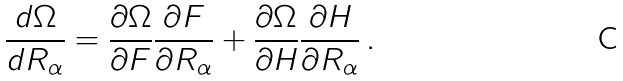Convert formula to latex. <formula><loc_0><loc_0><loc_500><loc_500>\frac { d \Omega } { d R _ { \alpha } } = \frac { \partial \Omega } { \partial F } \frac { \partial F } { \partial R _ { \alpha } } + \frac { \partial \Omega } { \partial H } \frac { \partial H } { \partial R _ { \alpha } } \, .</formula> 